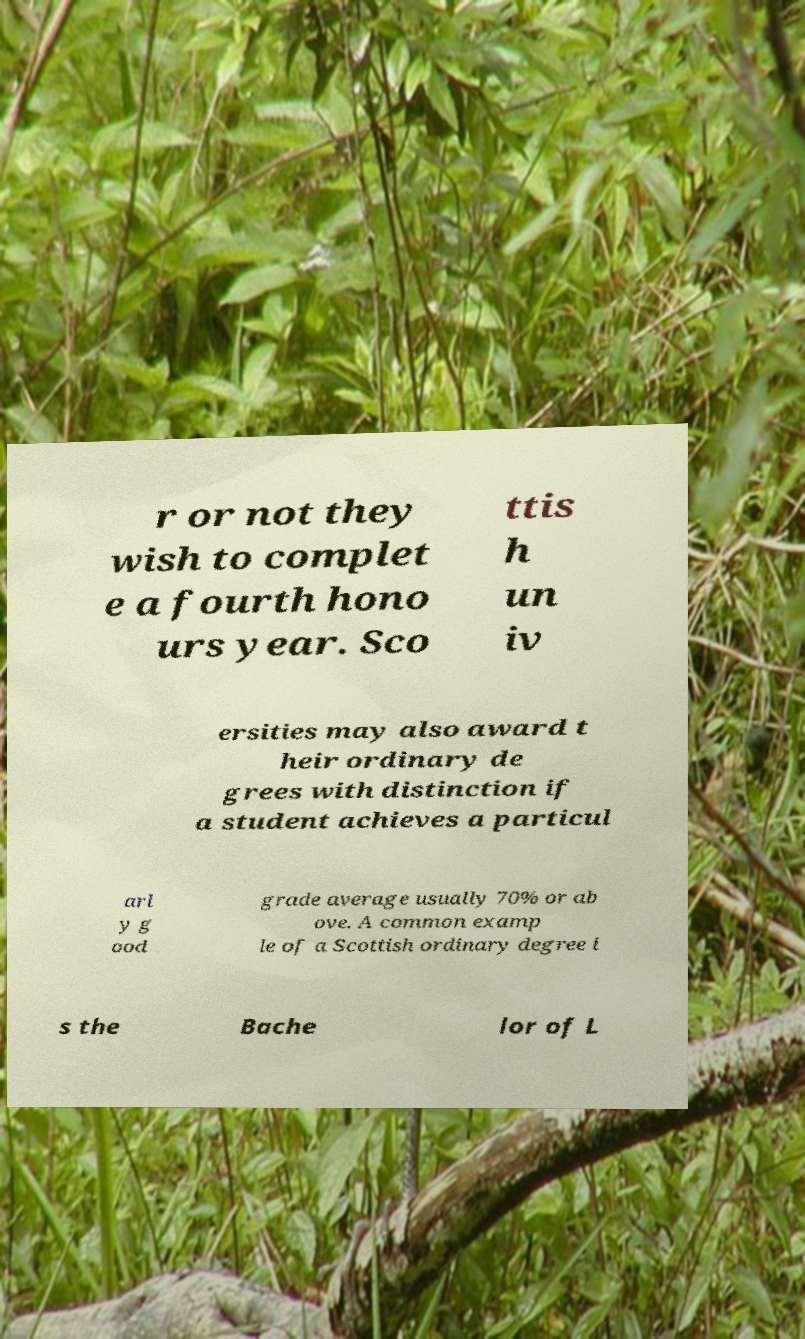Please identify and transcribe the text found in this image. r or not they wish to complet e a fourth hono urs year. Sco ttis h un iv ersities may also award t heir ordinary de grees with distinction if a student achieves a particul arl y g ood grade average usually 70% or ab ove. A common examp le of a Scottish ordinary degree i s the Bache lor of L 